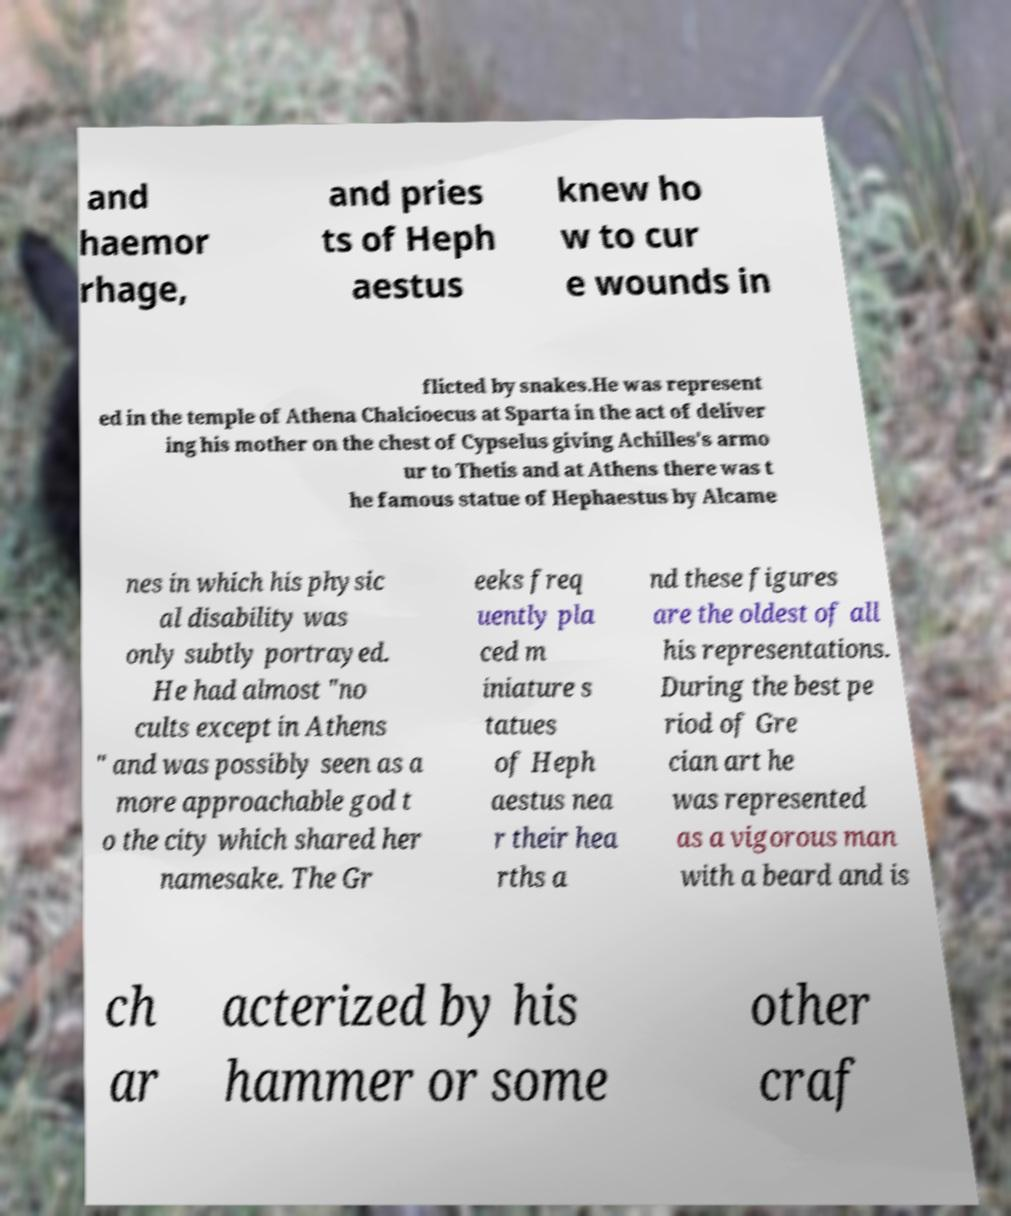Please identify and transcribe the text found in this image. and haemor rhage, and pries ts of Heph aestus knew ho w to cur e wounds in flicted by snakes.He was represent ed in the temple of Athena Chalcioecus at Sparta in the act of deliver ing his mother on the chest of Cypselus giving Achilles's armo ur to Thetis and at Athens there was t he famous statue of Hephaestus by Alcame nes in which his physic al disability was only subtly portrayed. He had almost "no cults except in Athens " and was possibly seen as a more approachable god t o the city which shared her namesake. The Gr eeks freq uently pla ced m iniature s tatues of Heph aestus nea r their hea rths a nd these figures are the oldest of all his representations. During the best pe riod of Gre cian art he was represented as a vigorous man with a beard and is ch ar acterized by his hammer or some other craf 